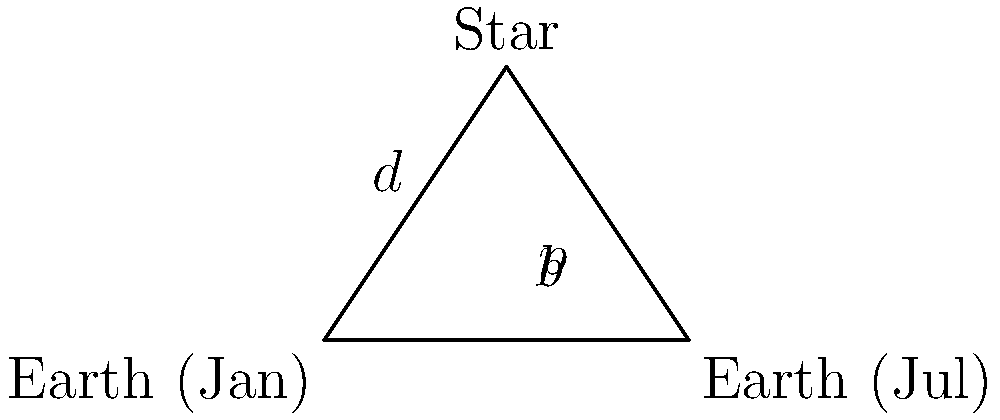As an astrophysicist, you're determining the distance to a distant star using the parallax method. The baseline (distance between Earth's positions in January and July) is 2 AU, and the measured parallax angle is 0.5 arcseconds. Calculate the distance to the star in parsecs. Let's approach this step-by-step:

1) First, recall that 1 parsec is defined as the distance at which an object has a parallax of 1 arcsecond when observed from points 1 AU apart.

2) In this case, we have:
   - Baseline $b = 2$ AU
   - Parallax angle $p = 0.5$ arcseconds

3) We need to use the small angle approximation for tangent:

   $\tan(p) \approx p$ (when $p$ is very small and in radians)

4) The relationship between distance $d$ (in parsecs) and parallax $p$ (in arcseconds) is:

   $d = \frac{1}{p}$ (when $b = 1$ AU)

5) However, our baseline is 2 AU, so we need to adjust the formula:

   $d = \frac{2}{p}$

6) Now we can simply plug in our value for $p$:

   $d = \frac{2}{0.5} = 4$ parsecs

Therefore, the star is 4 parsecs away from Earth.
Answer: 4 parsecs 